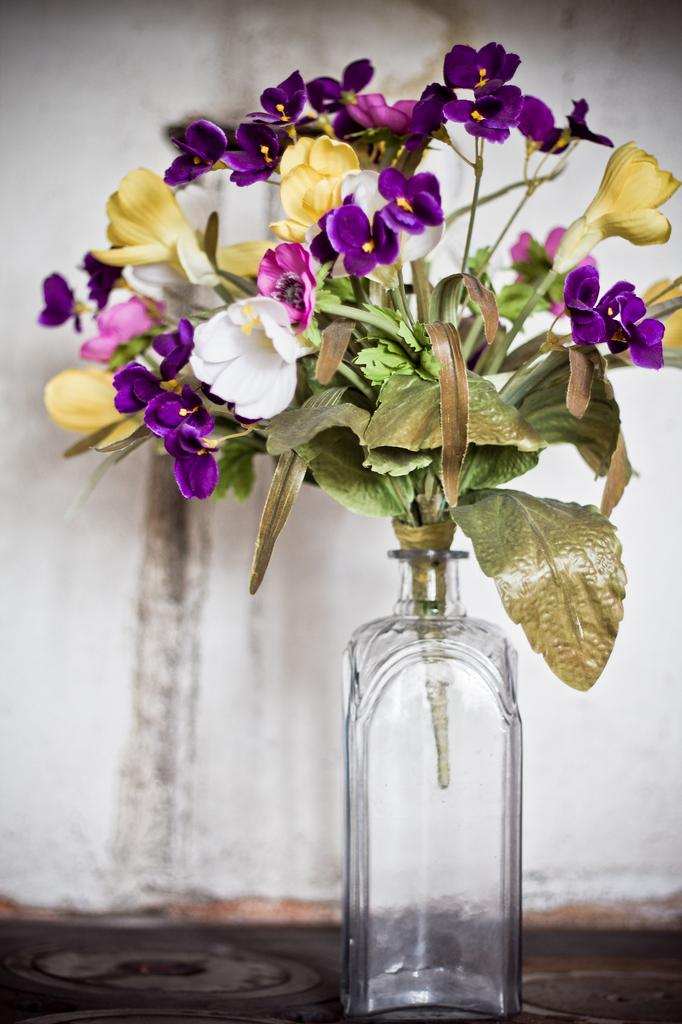What object is present in the image that is typically used for holding liquids? There is a glass bottle in the image. What is inside the glass bottle? There is a flower plant inside the glass bottle. What verse can be seen written on the bike in the image? There is no bike present in the image, so there is no verse to be seen. 